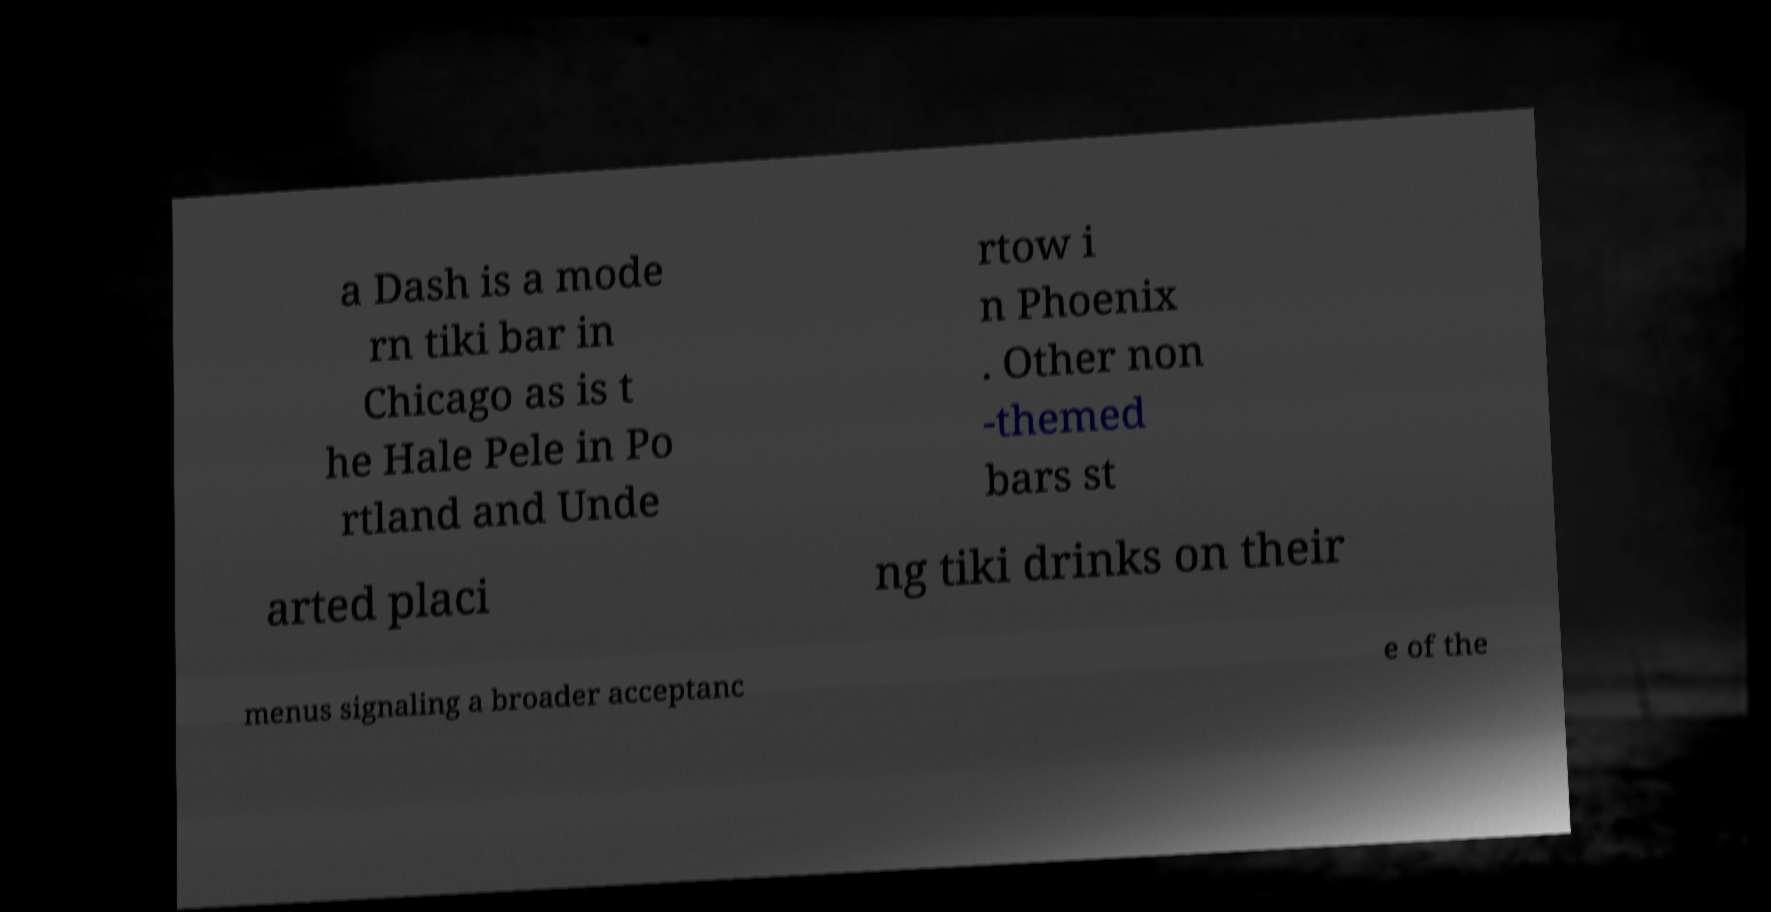Could you assist in decoding the text presented in this image and type it out clearly? a Dash is a mode rn tiki bar in Chicago as is t he Hale Pele in Po rtland and Unde rtow i n Phoenix . Other non -themed bars st arted placi ng tiki drinks on their menus signaling a broader acceptanc e of the 